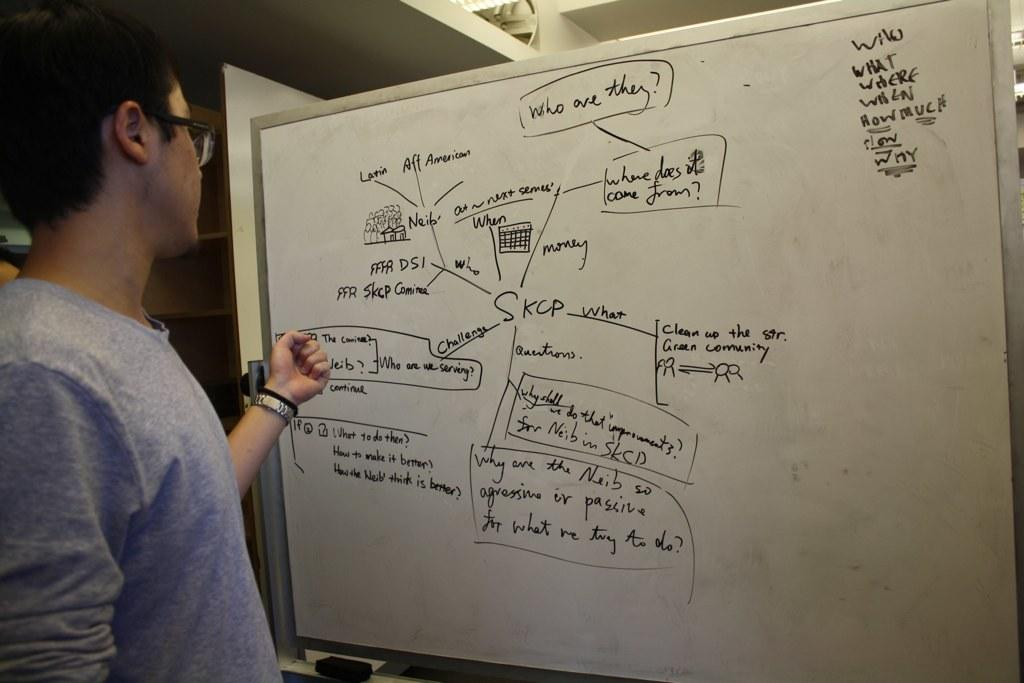<image>
Relay a brief, clear account of the picture shown. A man with glasses looks at a whiteboard that asks who are they? to the reader. 